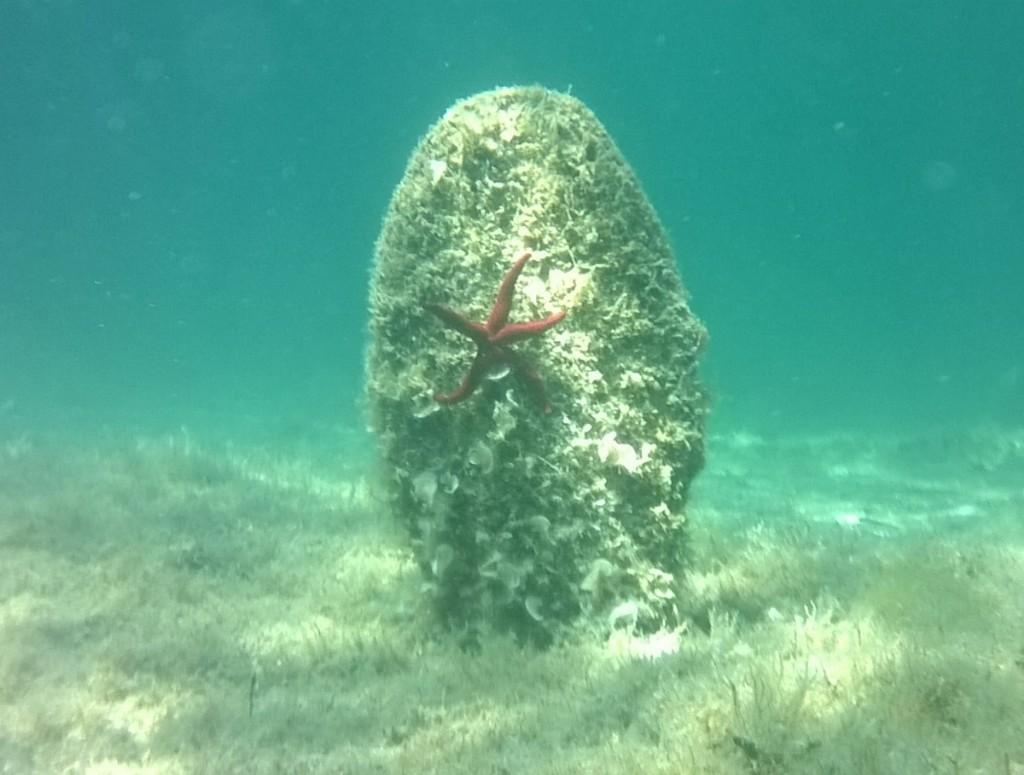What type of marine animal is in the image? There is a starfish in the image. What can be seen in the background of the image? There are underwater corals in the image. What type of knowledge can be gained from the starfish in the image? The image does not convey any specific knowledge or information about the starfish; it simply shows the starfish and underwater corals. 